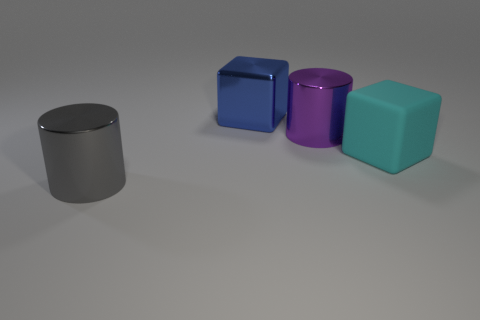Add 3 blue cylinders. How many objects exist? 7 Add 3 big objects. How many big objects exist? 7 Subtract 0 gray spheres. How many objects are left? 4 Subtract all blue matte objects. Subtract all big gray cylinders. How many objects are left? 3 Add 4 big gray cylinders. How many big gray cylinders are left? 5 